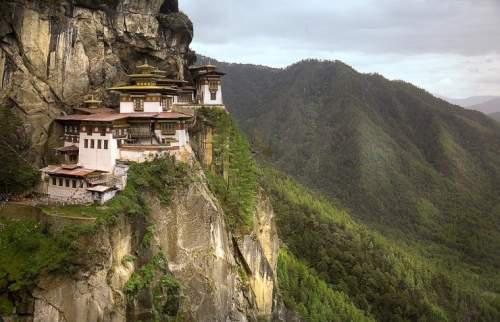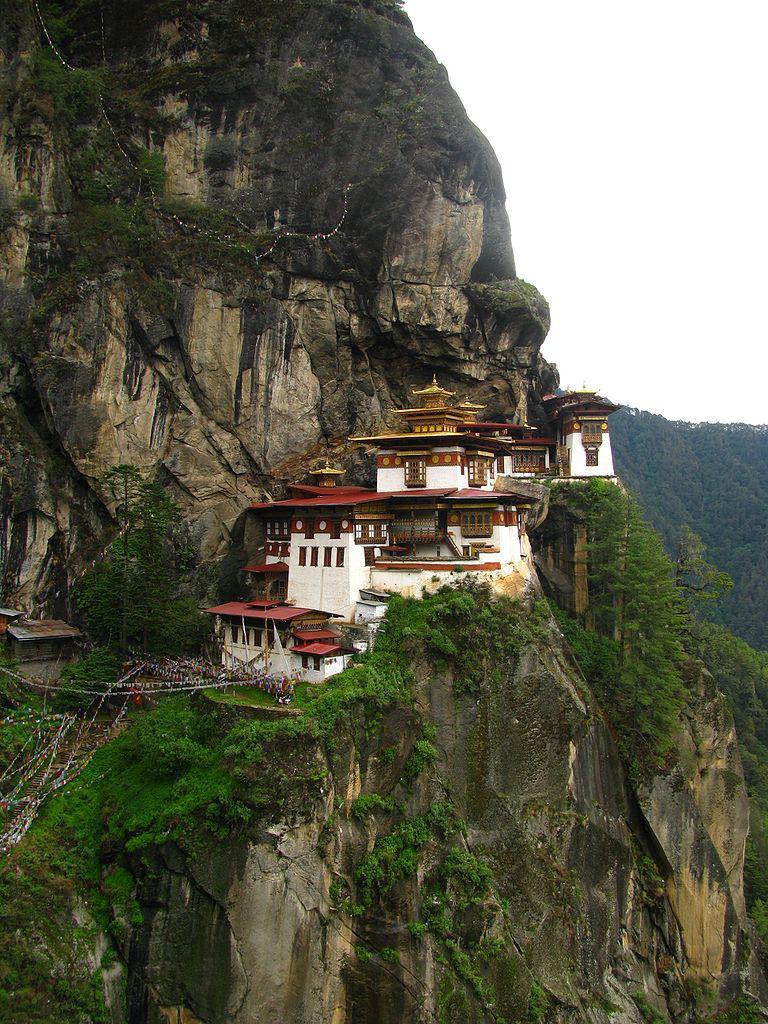The first image is the image on the left, the second image is the image on the right. Evaluate the accuracy of this statement regarding the images: "In at least one image there are people outside of a monastery.". Is it true? Answer yes or no. No. 